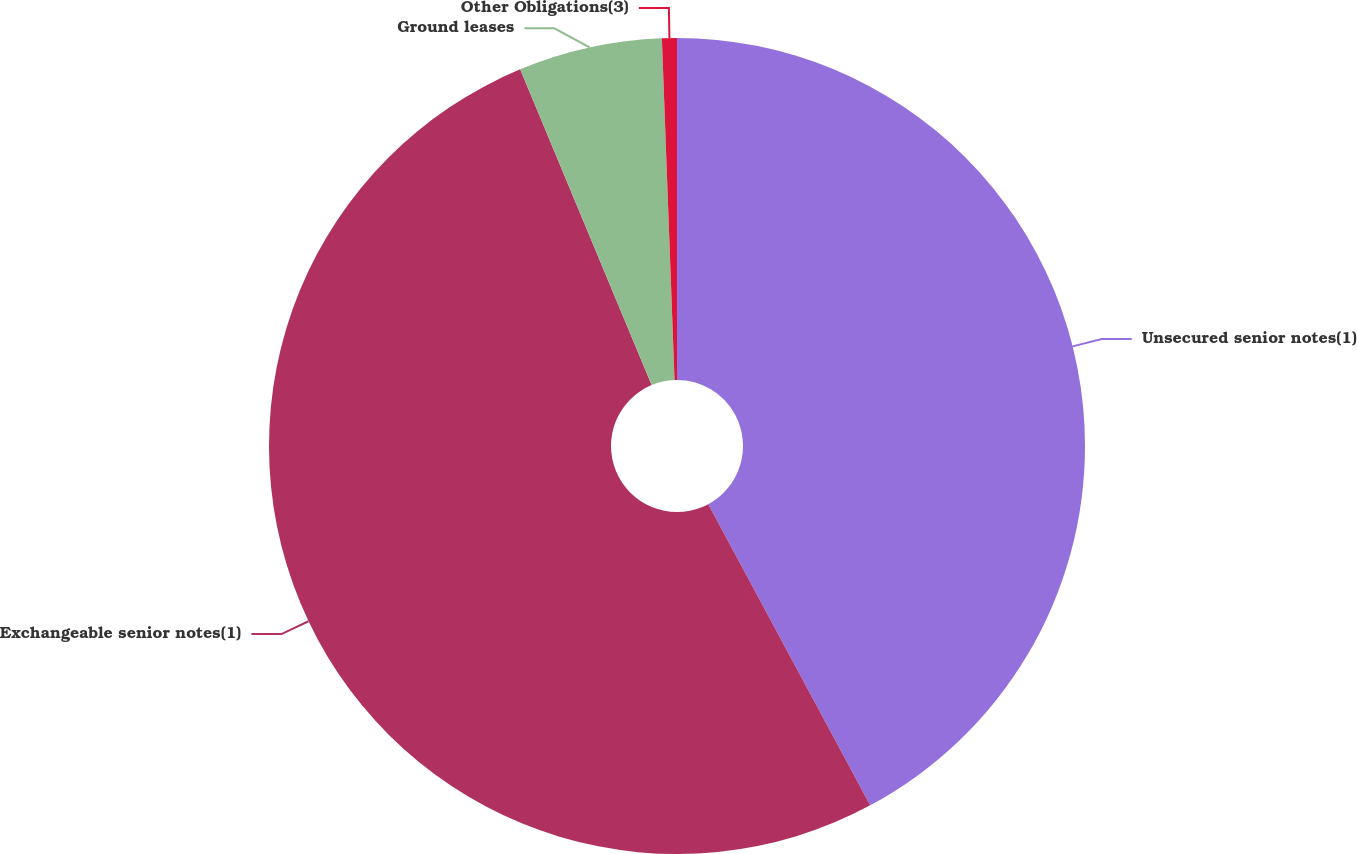Convert chart. <chart><loc_0><loc_0><loc_500><loc_500><pie_chart><fcel>Unsecured senior notes(1)<fcel>Exchangeable senior notes(1)<fcel>Ground leases<fcel>Other Obligations(3)<nl><fcel>42.15%<fcel>51.57%<fcel>5.69%<fcel>0.59%<nl></chart> 